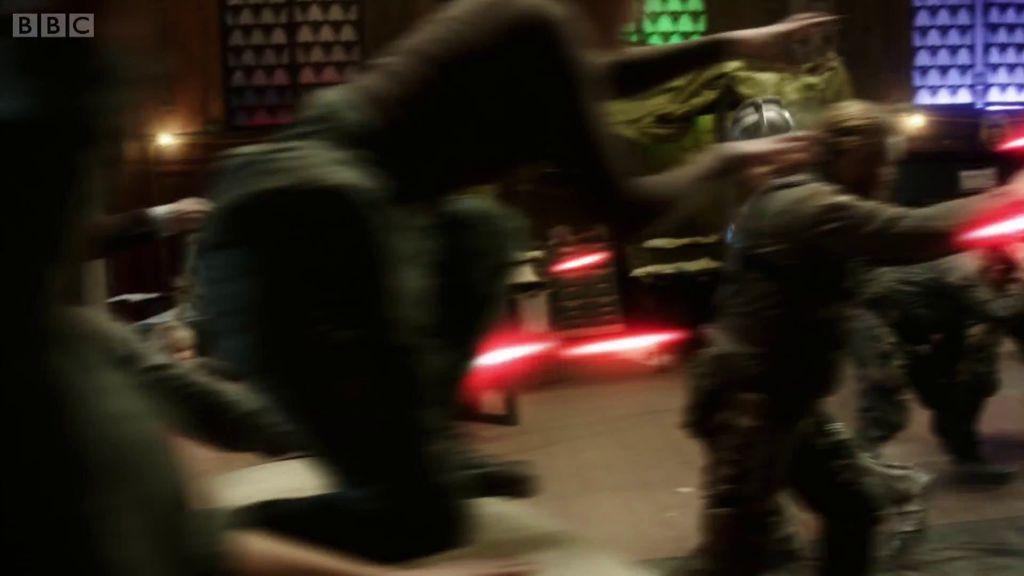How would you summarize this image in a sentence or two? In this image, we can see people and lights. There is a text in the top left of the image. In the background, we can see a wall. There are windows at the top of the image. 